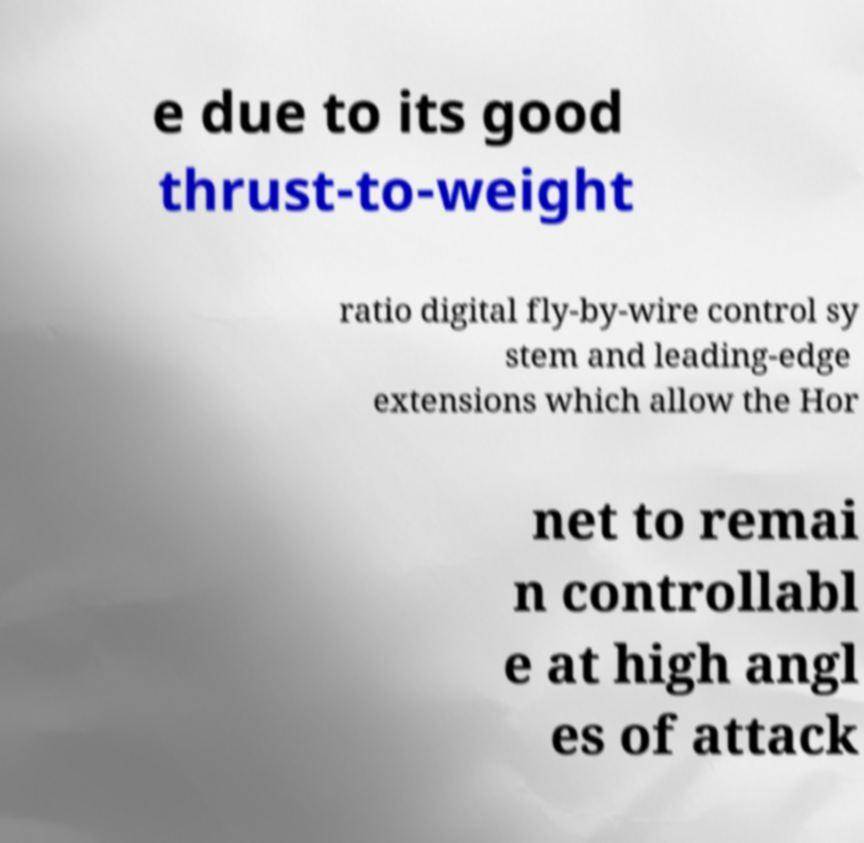Can you read and provide the text displayed in the image?This photo seems to have some interesting text. Can you extract and type it out for me? e due to its good thrust-to-weight ratio digital fly-by-wire control sy stem and leading-edge extensions which allow the Hor net to remai n controllabl e at high angl es of attack 